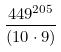<formula> <loc_0><loc_0><loc_500><loc_500>\frac { 4 4 9 ^ { 2 0 5 } } { ( 1 0 \cdot 9 ) }</formula> 